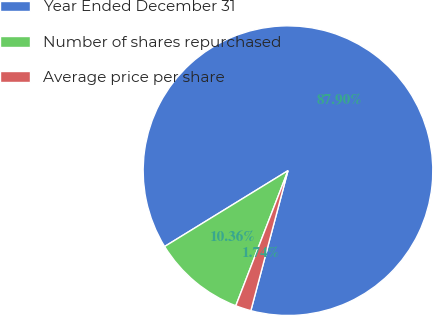Convert chart. <chart><loc_0><loc_0><loc_500><loc_500><pie_chart><fcel>Year Ended December 31<fcel>Number of shares repurchased<fcel>Average price per share<nl><fcel>87.9%<fcel>10.36%<fcel>1.74%<nl></chart> 